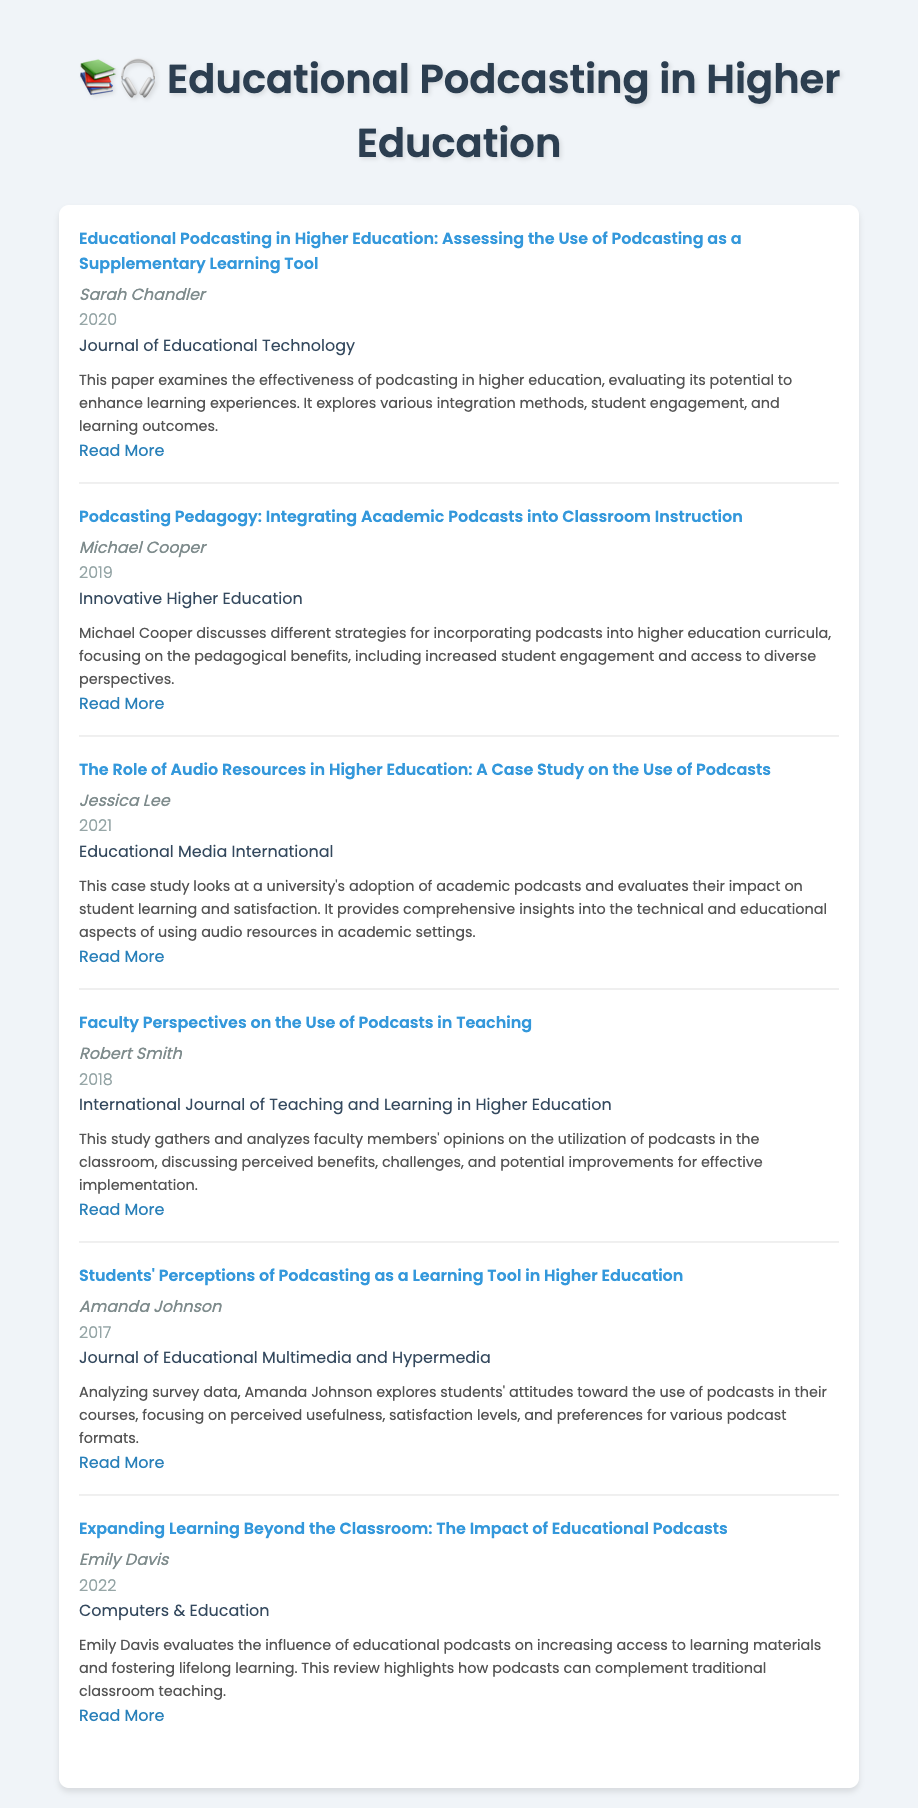What is the title of the paper by Sarah Chandler? The title of the paper can be found in the entry for Sarah Chandler, which specifically lists her work.
Answer: Educational Podcasting in Higher Education: Assessing the Use of Podcasting as a Supplementary Learning Tool Who authored the study on faculty perspectives regarding podcasts? The author's name is provided in the entry that discusses faculty views on podcast utilization.
Answer: Robert Smith In what year was the paper by Amanda Johnson published? The publication year is indicated in the entry for Amanda Johnson's research on students' perceptions of podcasting.
Answer: 2017 Which journal published the article written by Emily Davis? The name of the publisher is listed in Emily Davis's entry regarding the impact of educational podcasts.
Answer: Computers & Education How many authors contributed to the bibliography? The number of unique authors can be calculated by counting the different names listed throughout the entries.
Answer: 6 What is the focus of the paper authored by Jessica Lee? The focus or subject matter of the paper can be derived from the abstract in Jessica Lee's entry.
Answer: A case study on the use of podcasts What kind of sources does this bibliography compile? The type of sources is defined by the content and context of the document pertaining to educational tools in academia.
Answer: Academic audio resources Which entry discusses the integration of podcasts into classroom instruction? The title of the entry addressing this topic is explicitly mentioned in the relevant section of the document.
Answer: Podcasting Pedagogy: Integrating Academic Podcasts into Classroom Instruction 